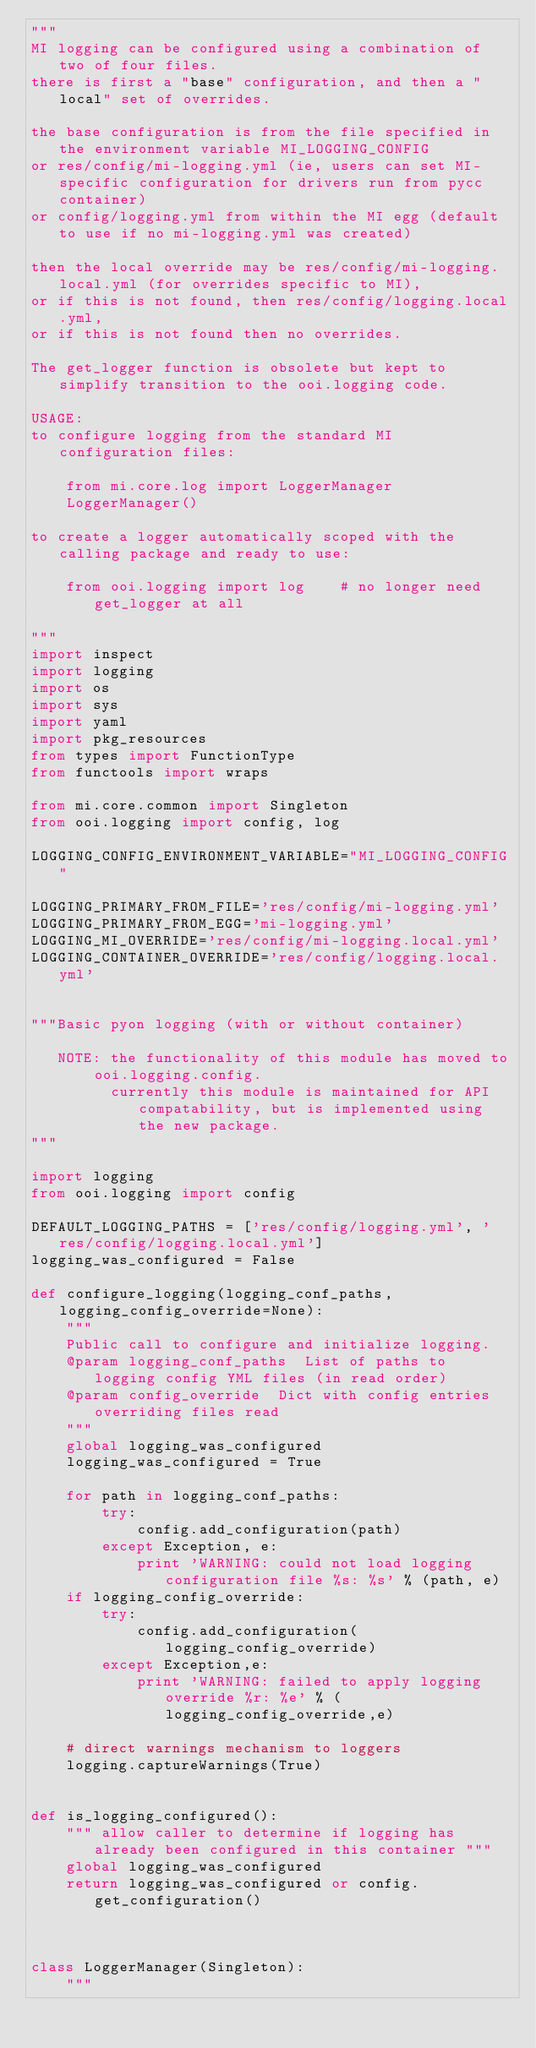<code> <loc_0><loc_0><loc_500><loc_500><_Python_>"""
MI logging can be configured using a combination of two of four files.
there is first a "base" configuration, and then a "local" set of overrides.

the base configuration is from the file specified in the environment variable MI_LOGGING_CONFIG
or res/config/mi-logging.yml (ie, users can set MI-specific configuration for drivers run from pycc container)
or config/logging.yml from within the MI egg (default to use if no mi-logging.yml was created)

then the local override may be res/config/mi-logging.local.yml (for overrides specific to MI),
or if this is not found, then res/config/logging.local.yml,
or if this is not found then no overrides.

The get_logger function is obsolete but kept to simplify transition to the ooi.logging code.

USAGE:
to configure logging from the standard MI configuration files:

    from mi.core.log import LoggerManager
    LoggerManager()

to create a logger automatically scoped with the calling package and ready to use:

    from ooi.logging import log    # no longer need get_logger at all

"""
import inspect
import logging
import os
import sys
import yaml
import pkg_resources
from types import FunctionType
from functools import wraps

from mi.core.common import Singleton
from ooi.logging import config, log

LOGGING_CONFIG_ENVIRONMENT_VARIABLE="MI_LOGGING_CONFIG"

LOGGING_PRIMARY_FROM_FILE='res/config/mi-logging.yml'
LOGGING_PRIMARY_FROM_EGG='mi-logging.yml'
LOGGING_MI_OVERRIDE='res/config/mi-logging.local.yml'
LOGGING_CONTAINER_OVERRIDE='res/config/logging.local.yml'


"""Basic pyon logging (with or without container)

   NOTE: the functionality of this module has moved to ooi.logging.config.
         currently this module is maintained for API compatability, but is implemented using the new package.
"""

import logging
from ooi.logging import config

DEFAULT_LOGGING_PATHS = ['res/config/logging.yml', 'res/config/logging.local.yml']
logging_was_configured = False

def configure_logging(logging_conf_paths, logging_config_override=None):
    """
    Public call to configure and initialize logging.
    @param logging_conf_paths  List of paths to logging config YML files (in read order)
    @param config_override  Dict with config entries overriding files read
    """
    global logging_was_configured
    logging_was_configured = True

    for path in logging_conf_paths:
        try:
            config.add_configuration(path)
        except Exception, e:
            print 'WARNING: could not load logging configuration file %s: %s' % (path, e)
    if logging_config_override:
        try:
            config.add_configuration(logging_config_override)
        except Exception,e:
            print 'WARNING: failed to apply logging override %r: %e' % (logging_config_override,e)

    # direct warnings mechanism to loggers
    logging.captureWarnings(True)


def is_logging_configured():
    """ allow caller to determine if logging has already been configured in this container """
    global logging_was_configured
    return logging_was_configured or config.get_configuration()



class LoggerManager(Singleton):
    """</code> 